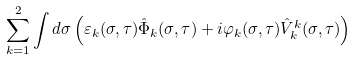Convert formula to latex. <formula><loc_0><loc_0><loc_500><loc_500>\sum _ { k = 1 } ^ { 2 } \int d \sigma \left ( \varepsilon _ { k } ( \sigma , \tau ) \hat { \Phi } _ { k } ( \sigma , \tau ) + i \varphi _ { k } ( \sigma , \tau ) \hat { V } _ { k } ^ { k } ( \sigma , \tau ) \right )</formula> 